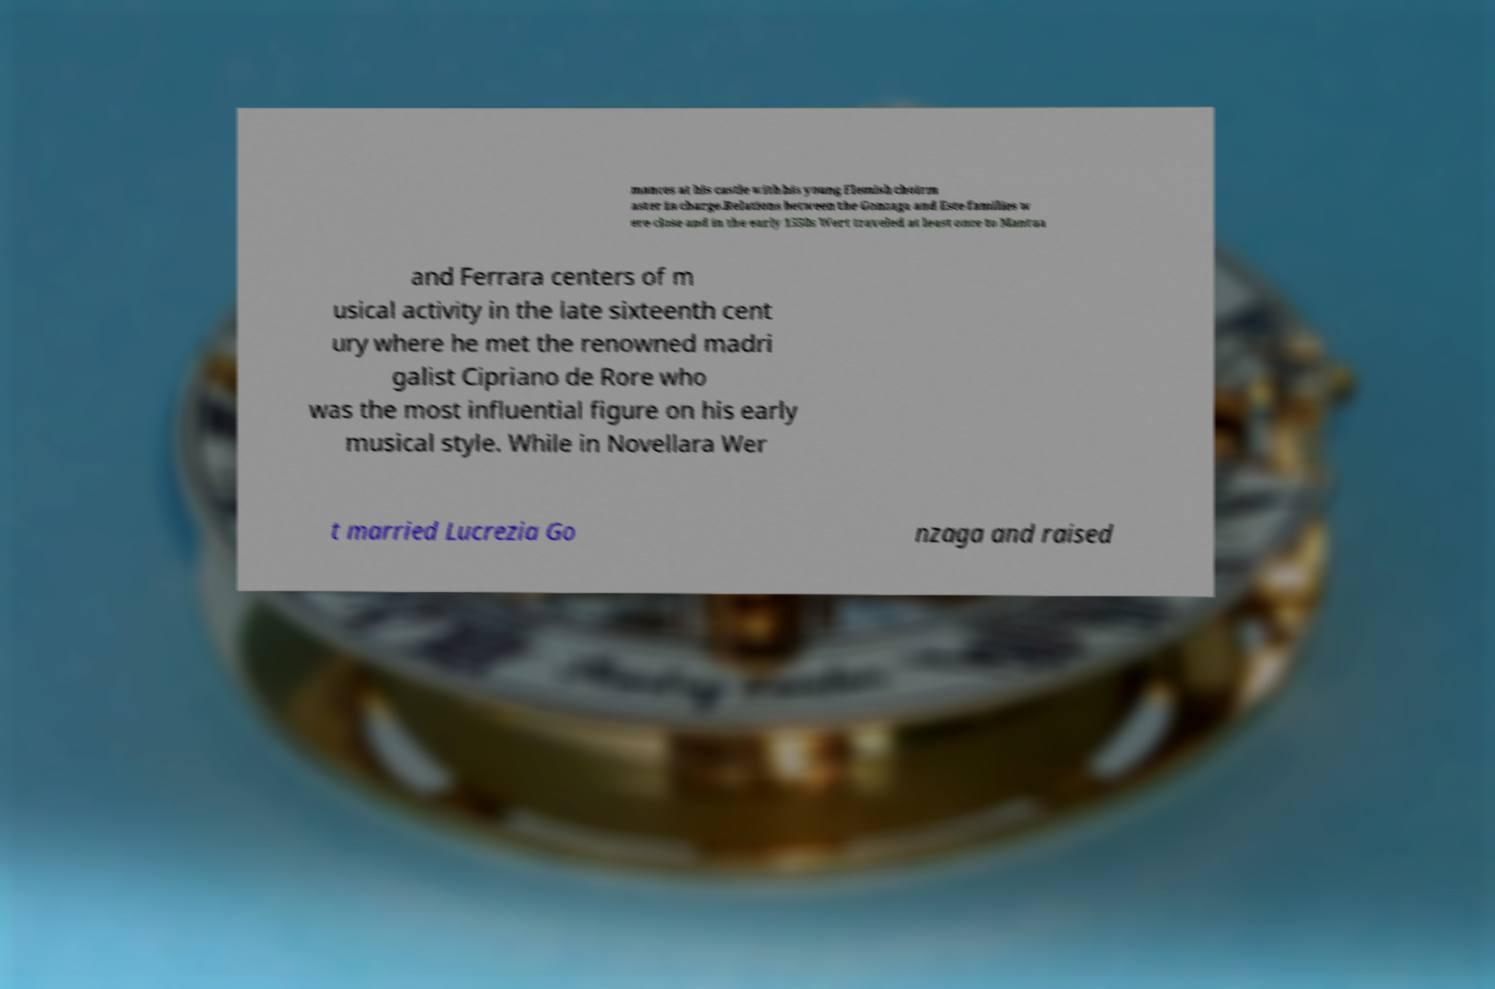Could you extract and type out the text from this image? mances at his castle with his young Flemish choirm aster in charge.Relations between the Gonzaga and Este families w ere close and in the early 1550s Wert traveled at least once to Mantua and Ferrara centers of m usical activity in the late sixteenth cent ury where he met the renowned madri galist Cipriano de Rore who was the most influential figure on his early musical style. While in Novellara Wer t married Lucrezia Go nzaga and raised 